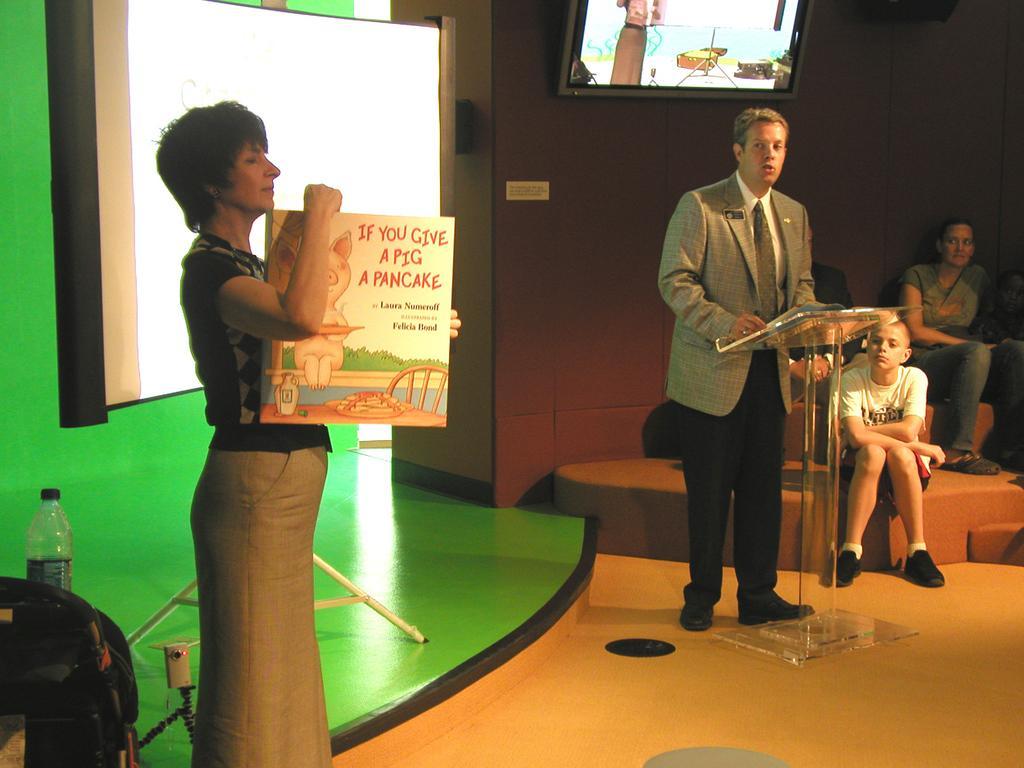How would you summarize this image in a sentence or two? In the image we can see there is a woman standing and holding book in her hand. There is a man standing near the podium and there are people sitting on the stairs at the back. Behind there is projector screen on the wall and there is a tv kept on the wall. 